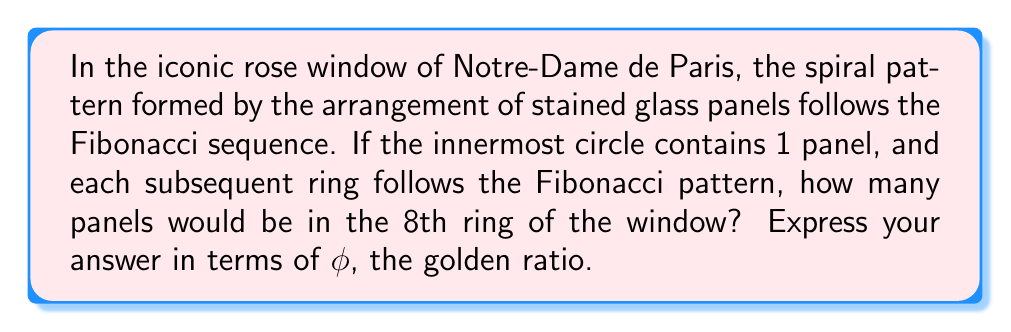Show me your answer to this math problem. Let's approach this step-by-step:

1) First, recall that the Fibonacci sequence is: 1, 1, 2, 3, 5, 8, 13, 21, ...

2) The 8th term in this sequence is 21, which represents the number of panels in the 8th ring.

3) Now, we need to express this in terms of $\phi$, the golden ratio. The golden ratio is defined as:

   $$\phi = \frac{1 + \sqrt{5}}{2} \approx 1.618033989$$

4) There's a remarkable formula that relates the nth Fibonacci number ($F_n$) to $\phi$:

   $$F_n = \frac{\phi^n - (-\phi)^{-n}}{\sqrt{5}}$$

5) In our case, n = 8, so we need to calculate $F_8$:

   $$F_8 = \frac{\phi^8 - (-\phi)^{-8}}{\sqrt{5}}$$

6) Expanding this:

   $$F_8 = \frac{\phi^8 - (-1)^8(\phi^{-8})}{\sqrt{5}} = \frac{\phi^8 - \phi^{-8}}{\sqrt{5}}$$

7) This is the exact expression for the 21 panels in the 8th ring in terms of $\phi$.
Answer: $\frac{\phi^8 - \phi^{-8}}{\sqrt{5}}$ 